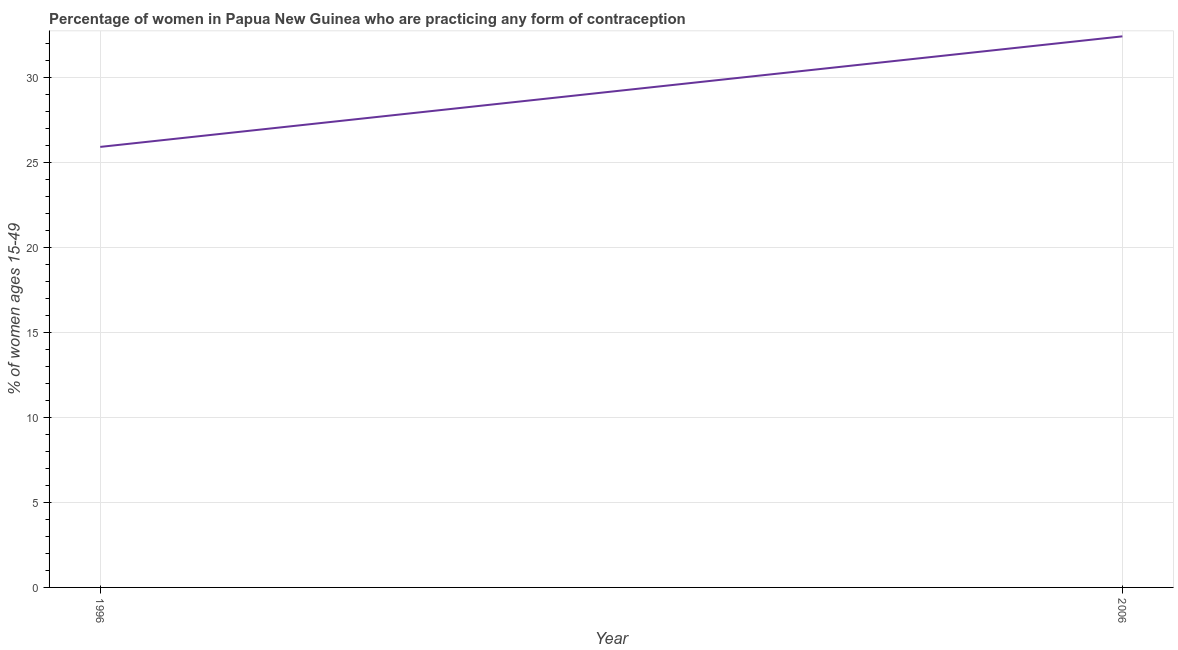What is the contraceptive prevalence in 2006?
Provide a short and direct response. 32.4. Across all years, what is the maximum contraceptive prevalence?
Offer a terse response. 32.4. Across all years, what is the minimum contraceptive prevalence?
Ensure brevity in your answer.  25.9. In which year was the contraceptive prevalence minimum?
Ensure brevity in your answer.  1996. What is the sum of the contraceptive prevalence?
Offer a very short reply. 58.3. What is the difference between the contraceptive prevalence in 1996 and 2006?
Offer a terse response. -6.5. What is the average contraceptive prevalence per year?
Offer a very short reply. 29.15. What is the median contraceptive prevalence?
Keep it short and to the point. 29.15. In how many years, is the contraceptive prevalence greater than 29 %?
Ensure brevity in your answer.  1. What is the ratio of the contraceptive prevalence in 1996 to that in 2006?
Keep it short and to the point. 0.8. In how many years, is the contraceptive prevalence greater than the average contraceptive prevalence taken over all years?
Offer a terse response. 1. Does the contraceptive prevalence monotonically increase over the years?
Make the answer very short. Yes. How many years are there in the graph?
Your answer should be very brief. 2. What is the difference between two consecutive major ticks on the Y-axis?
Your answer should be compact. 5. Does the graph contain grids?
Your response must be concise. Yes. What is the title of the graph?
Keep it short and to the point. Percentage of women in Papua New Guinea who are practicing any form of contraception. What is the label or title of the X-axis?
Your answer should be very brief. Year. What is the label or title of the Y-axis?
Offer a terse response. % of women ages 15-49. What is the % of women ages 15-49 of 1996?
Your response must be concise. 25.9. What is the % of women ages 15-49 of 2006?
Offer a terse response. 32.4. What is the ratio of the % of women ages 15-49 in 1996 to that in 2006?
Make the answer very short. 0.8. 